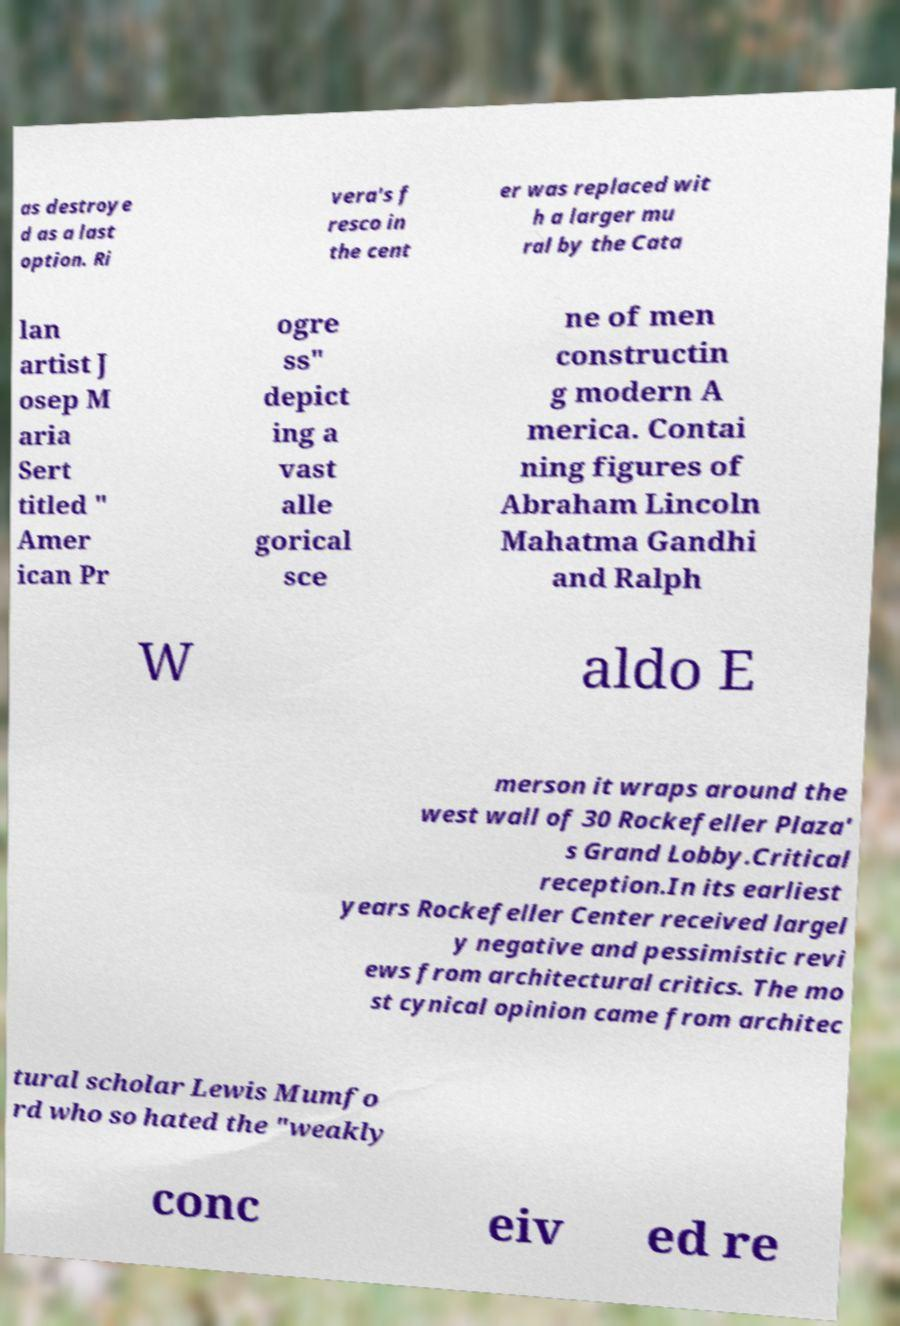Can you read and provide the text displayed in the image?This photo seems to have some interesting text. Can you extract and type it out for me? as destroye d as a last option. Ri vera's f resco in the cent er was replaced wit h a larger mu ral by the Cata lan artist J osep M aria Sert titled " Amer ican Pr ogre ss" depict ing a vast alle gorical sce ne of men constructin g modern A merica. Contai ning figures of Abraham Lincoln Mahatma Gandhi and Ralph W aldo E merson it wraps around the west wall of 30 Rockefeller Plaza' s Grand Lobby.Critical reception.In its earliest years Rockefeller Center received largel y negative and pessimistic revi ews from architectural critics. The mo st cynical opinion came from architec tural scholar Lewis Mumfo rd who so hated the "weakly conc eiv ed re 